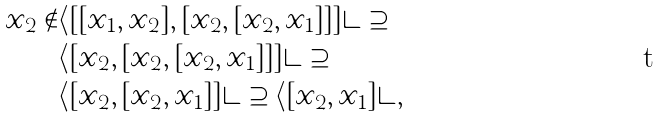<formula> <loc_0><loc_0><loc_500><loc_500>x _ { 2 } \notin & \langle [ [ x _ { 1 } , x _ { 2 } ] , [ x _ { 2 } , [ x _ { 2 } , x _ { 1 } ] ] ] \rangle \supseteq \\ & \langle [ x _ { 2 } , [ x _ { 2 } , [ x _ { 2 } , x _ { 1 } ] ] ] \rangle \supseteq \\ & \langle [ x _ { 2 } , [ x _ { 2 } , x _ { 1 } ] ] \rangle \supseteq \langle [ x _ { 2 } , x _ { 1 } ] \rangle ,</formula> 